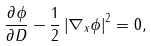Convert formula to latex. <formula><loc_0><loc_0><loc_500><loc_500>\frac { \partial \phi } { \partial D } - \frac { 1 } { 2 } \left | \nabla _ { x } \phi \right | ^ { 2 } = 0 ,</formula> 